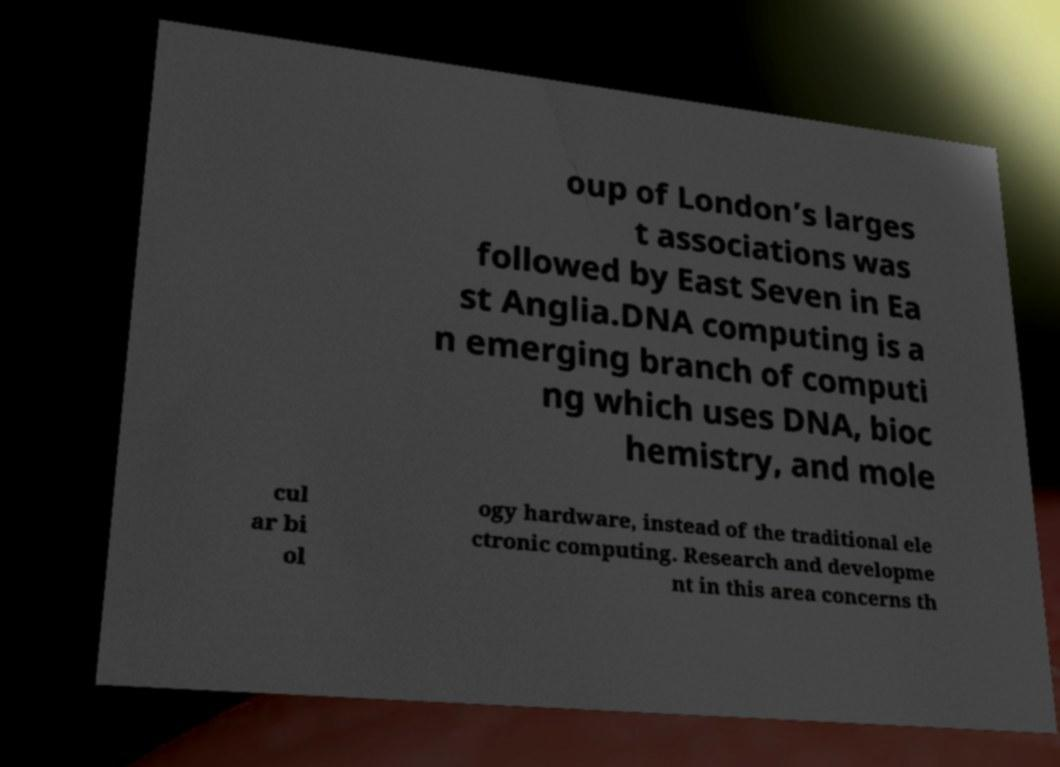Please identify and transcribe the text found in this image. oup of London’s larges t associations was followed by East Seven in Ea st Anglia.DNA computing is a n emerging branch of computi ng which uses DNA, bioc hemistry, and mole cul ar bi ol ogy hardware, instead of the traditional ele ctronic computing. Research and developme nt in this area concerns th 